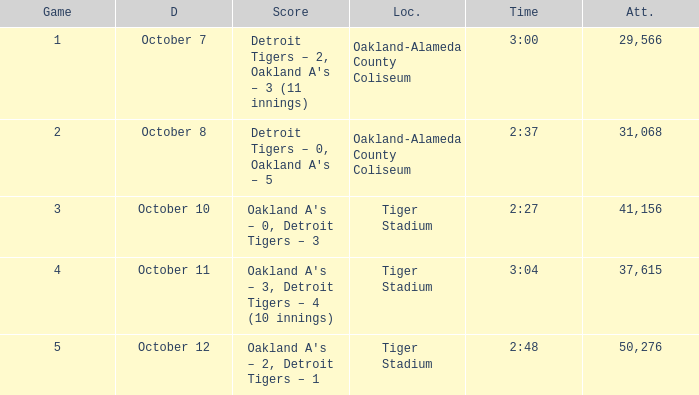What is the number of people in attendance at Oakland-Alameda County Coliseum, and game is 2? 31068.0. 